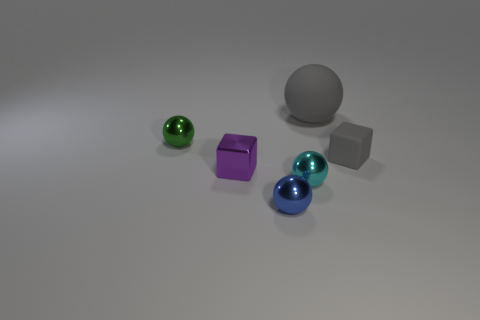There is a cube that is on the right side of the small cyan metal sphere; does it have the same size as the cyan metallic ball in front of the purple shiny cube?
Keep it short and to the point. Yes. What number of cyan things are either big shiny balls or large objects?
Offer a terse response. 0. What is the size of the other thing that is the same color as the big thing?
Give a very brief answer. Small. Are there more gray cubes than red cylinders?
Offer a terse response. Yes. Do the small matte cube and the large object have the same color?
Keep it short and to the point. Yes. What number of objects are either green balls or tiny metal objects that are in front of the small gray cube?
Your answer should be compact. 4. How many other objects are the same shape as the big object?
Make the answer very short. 3. Are there fewer small gray things that are right of the gray sphere than cyan metallic things that are behind the small purple metal object?
Your answer should be compact. No. Is there anything else that is made of the same material as the small cyan ball?
Offer a very short reply. Yes. There is a cyan thing that is made of the same material as the green thing; what shape is it?
Keep it short and to the point. Sphere. 